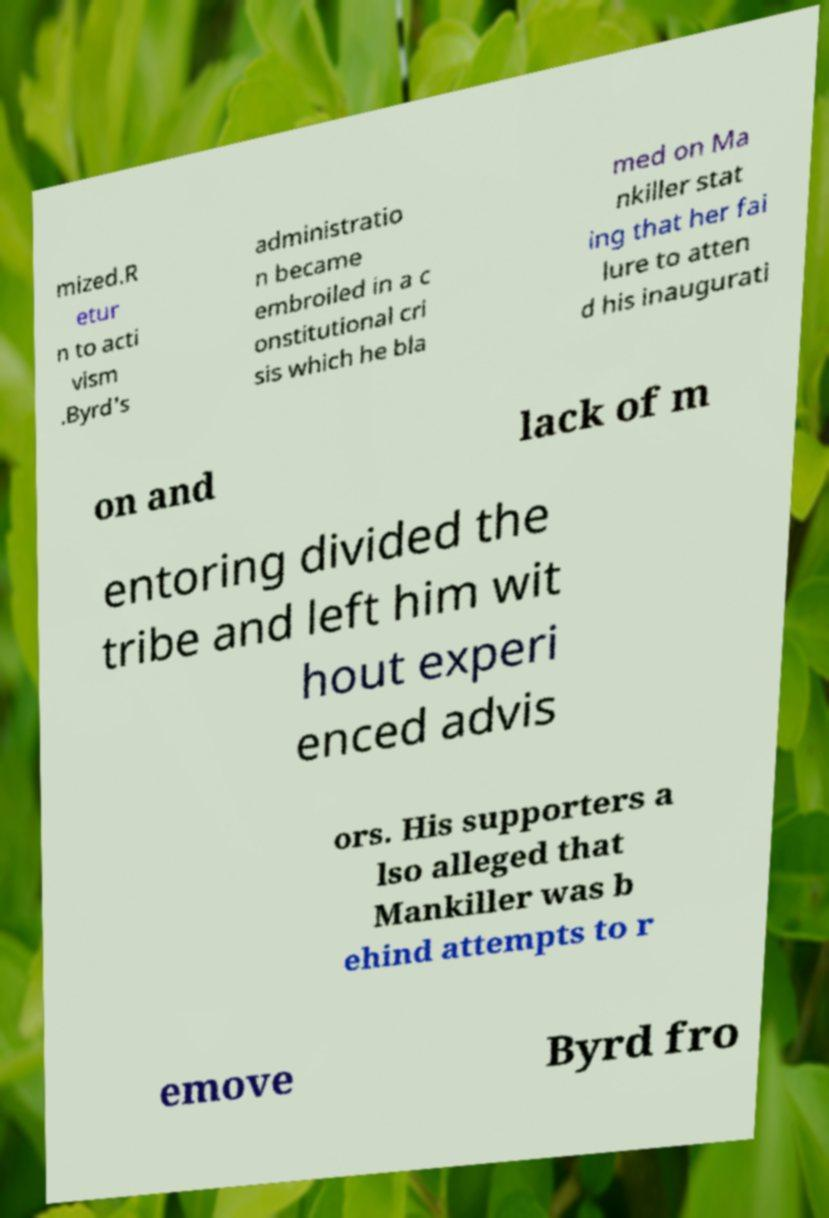There's text embedded in this image that I need extracted. Can you transcribe it verbatim? mized.R etur n to acti vism .Byrd's administratio n became embroiled in a c onstitutional cri sis which he bla med on Ma nkiller stat ing that her fai lure to atten d his inaugurati on and lack of m entoring divided the tribe and left him wit hout experi enced advis ors. His supporters a lso alleged that Mankiller was b ehind attempts to r emove Byrd fro 